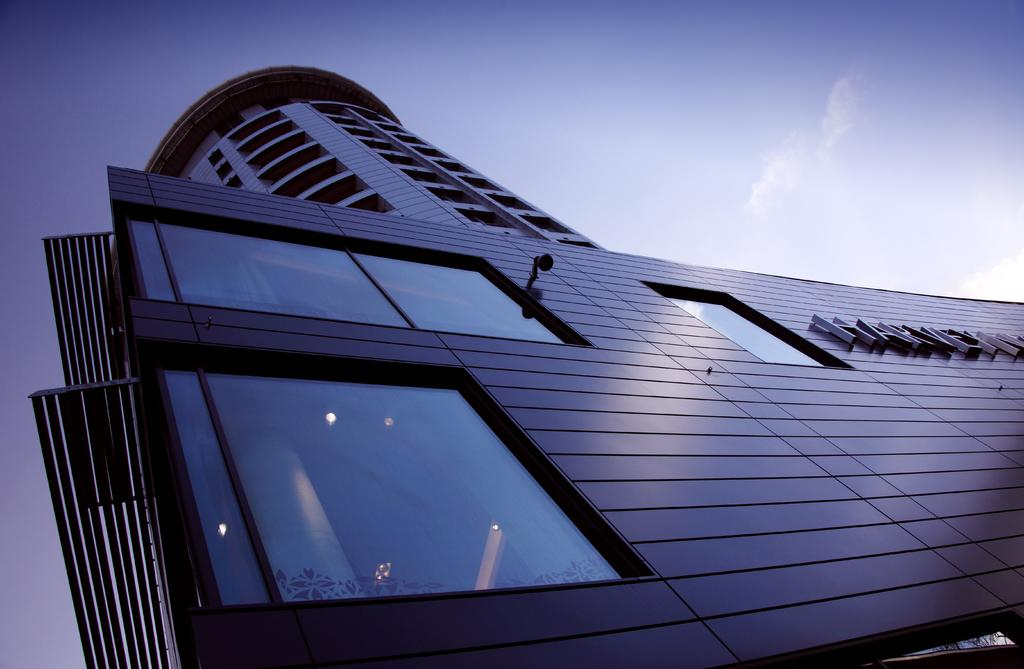What structure is depicted in the image? There is a building in the image. What is written or displayed on the building? There is text on the building. What can be seen behind a mirror in the image? There are lights behind a mirror in the image. What is visible at the top of the image? The sky is visible at the top of the image. What can be observed in the sky? There are clouds in the sky. What type of cabbage is growing on the roof of the building in the image? There is no cabbage visible on the roof of the building in the image. 